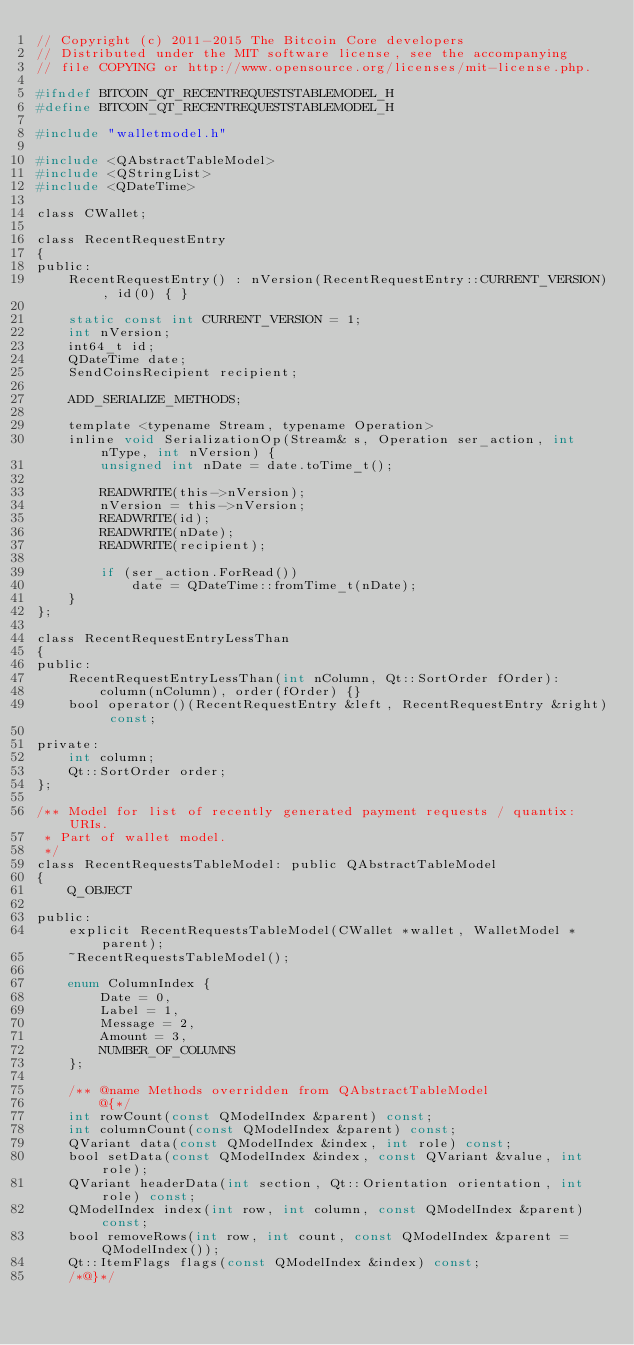Convert code to text. <code><loc_0><loc_0><loc_500><loc_500><_C_>// Copyright (c) 2011-2015 The Bitcoin Core developers
// Distributed under the MIT software license, see the accompanying
// file COPYING or http://www.opensource.org/licenses/mit-license.php.

#ifndef BITCOIN_QT_RECENTREQUESTSTABLEMODEL_H
#define BITCOIN_QT_RECENTREQUESTSTABLEMODEL_H

#include "walletmodel.h"

#include <QAbstractTableModel>
#include <QStringList>
#include <QDateTime>

class CWallet;

class RecentRequestEntry
{
public:
    RecentRequestEntry() : nVersion(RecentRequestEntry::CURRENT_VERSION), id(0) { }

    static const int CURRENT_VERSION = 1;
    int nVersion;
    int64_t id;
    QDateTime date;
    SendCoinsRecipient recipient;

    ADD_SERIALIZE_METHODS;

    template <typename Stream, typename Operation>
    inline void SerializationOp(Stream& s, Operation ser_action, int nType, int nVersion) {
        unsigned int nDate = date.toTime_t();

        READWRITE(this->nVersion);
        nVersion = this->nVersion;
        READWRITE(id);
        READWRITE(nDate);
        READWRITE(recipient);

        if (ser_action.ForRead())
            date = QDateTime::fromTime_t(nDate);
    }
};

class RecentRequestEntryLessThan
{
public:
    RecentRequestEntryLessThan(int nColumn, Qt::SortOrder fOrder):
        column(nColumn), order(fOrder) {}
    bool operator()(RecentRequestEntry &left, RecentRequestEntry &right) const;

private:
    int column;
    Qt::SortOrder order;
};

/** Model for list of recently generated payment requests / quantix: URIs.
 * Part of wallet model.
 */
class RecentRequestsTableModel: public QAbstractTableModel
{
    Q_OBJECT

public:
    explicit RecentRequestsTableModel(CWallet *wallet, WalletModel *parent);
    ~RecentRequestsTableModel();

    enum ColumnIndex {
        Date = 0,
        Label = 1,
        Message = 2,
        Amount = 3,
        NUMBER_OF_COLUMNS
    };

    /** @name Methods overridden from QAbstractTableModel
        @{*/
    int rowCount(const QModelIndex &parent) const;
    int columnCount(const QModelIndex &parent) const;
    QVariant data(const QModelIndex &index, int role) const;
    bool setData(const QModelIndex &index, const QVariant &value, int role);
    QVariant headerData(int section, Qt::Orientation orientation, int role) const;
    QModelIndex index(int row, int column, const QModelIndex &parent) const;
    bool removeRows(int row, int count, const QModelIndex &parent = QModelIndex());
    Qt::ItemFlags flags(const QModelIndex &index) const;
    /*@}*/
</code> 